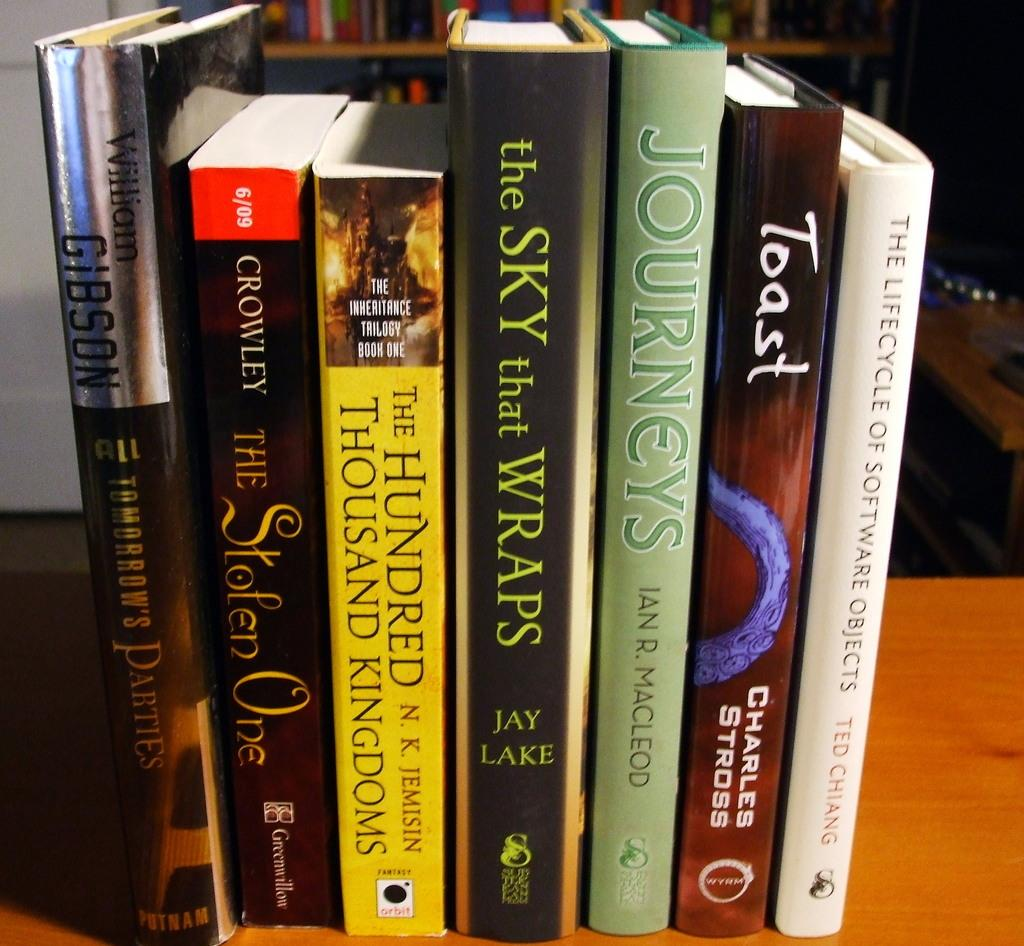What objects are on the table in the image? There are books on the table in the image. What can be seen in the background of the image? There is a bookshelf with books in the background of the image. What is visible on the right side of the image? There is a table on the right side of the image. What is the primary feature of the wall visible in the image? The fact does not specify any details about the wall, so we cannot answer this question definitively. What type of glass is being used to play a game on the table in the image? There is no glass or game present in the image; it features books on a table and a bookshelf in the background. Can you describe the spot on the wall where the painting is hung in the image? There is no painting or spot mentioned in the provided facts, so we cannot answer this question definitively. 